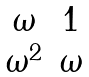<formula> <loc_0><loc_0><loc_500><loc_500>\begin{matrix} \omega & 1 \\ \omega ^ { 2 } & \omega \end{matrix}</formula> 